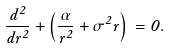<formula> <loc_0><loc_0><loc_500><loc_500>\frac { d ^ { 2 } \Psi } { d r ^ { 2 } } + \left ( \frac { \alpha } { r ^ { 2 } } + \sigma ^ { 2 } r \right ) \Psi = 0 .</formula> 